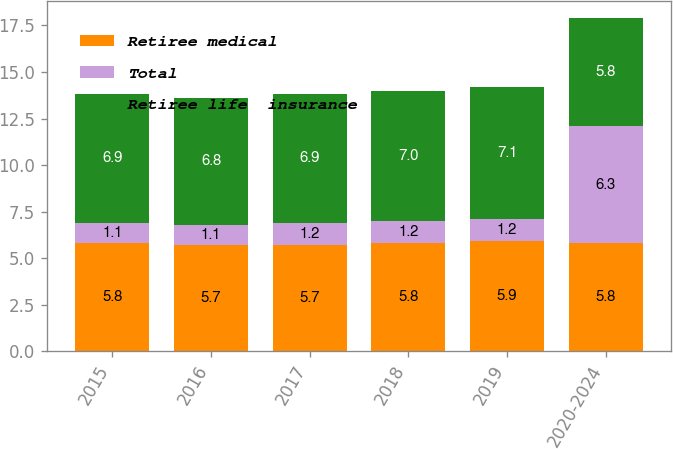Convert chart to OTSL. <chart><loc_0><loc_0><loc_500><loc_500><stacked_bar_chart><ecel><fcel>2015<fcel>2016<fcel>2017<fcel>2018<fcel>2019<fcel>2020-2024<nl><fcel>Retiree medical<fcel>5.8<fcel>5.7<fcel>5.7<fcel>5.8<fcel>5.9<fcel>5.8<nl><fcel>Total<fcel>1.1<fcel>1.1<fcel>1.2<fcel>1.2<fcel>1.2<fcel>6.3<nl><fcel>Retiree life  insurance<fcel>6.9<fcel>6.8<fcel>6.9<fcel>7<fcel>7.1<fcel>5.8<nl></chart> 